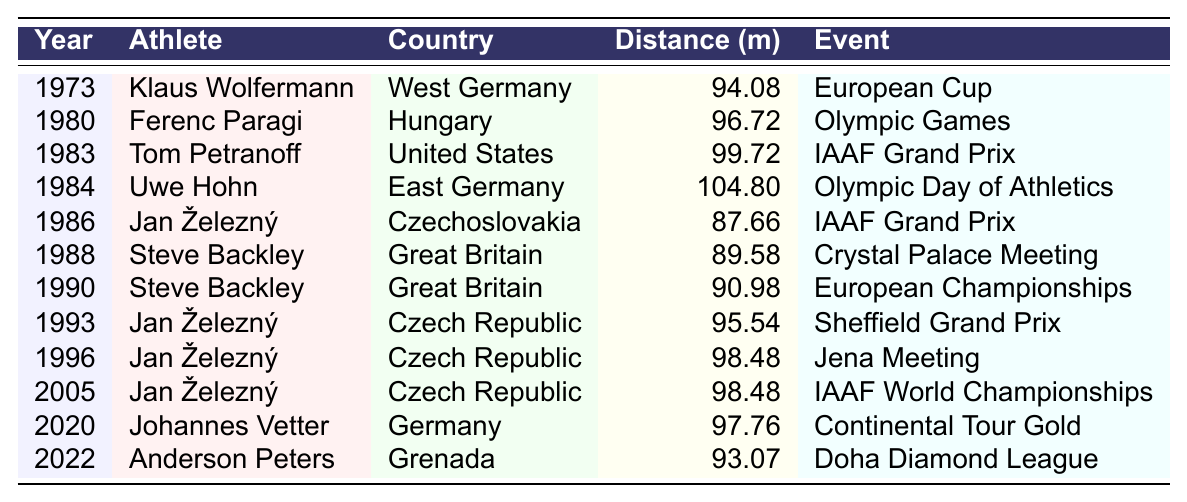What year did Uwe Hohn set the world record in javelin throw? According to the table, Uwe Hohn set the world record in 1984 during the Olympic Day of Athletics.
Answer: 1984 Which athlete had the highest throw distance according to the table? By checking the distances listed, Uwe Hohn achieved the highest throw of 104.80 meters in 1984.
Answer: Uwe Hohn How many athletes recorded throws over 90 meters? The athletes with throws over 90 meters are Klaus Wolfermann (94.08), Ferenc Paragi (96.72), Tom Petranoff (99.72), Uwe Hohn (104.80), Jan Železný (95.54, 98.48) and Johannes Vetter (97.76), making a total of 7 athletes.
Answer: 7 What is the average throw distance from the athletes listed since 1990? The throws since 1990 are 90.98, 95.54, 98.48, 98.48, 97.76, and 93.07. Summing these gives (90.98 + 95.54 + 98.48 + 98.48 + 97.76 + 93.07) = 574.31, and dividing by 6 gives an average of 574.31 / 6 = 95.72 meters.
Answer: 95.72 meters Did any athlete from Czechoslovakia set a world record? Yes, Jan Železný, who represented Czechoslovakia, recorded throws in 1986, but his best throws recorded were after the split when he represented the Czech Republic. However, he holds significant records in the javelin throw overall.
Answer: Yes What was the distance of the last recorded throw and who achieved it? The last recorded throw in the table is by Anderson Peters at 93.07 meters during the Doha Diamond League in 2022.
Answer: 93.07 meters, Anderson Peters How many different countries are represented in this javelin throw progression table? The countries represented are West Germany, Hungary, United States, East Germany, Czechoslovakia, Great Britain, Czech Republic, Germany, and Grenada. This totals to 9 different countries.
Answer: 9 What is the trend of javelin throw distances based on the data from the 1970s to the 2020s? The records show an overall increase in the distances, particularly with Uwe Hohn in 1984 reaching 104.80 meters, which is notably higher than earlier throws. The later throws mostly hover around the mid to high 90s.
Answer: Increase in distances with peak in 1984 